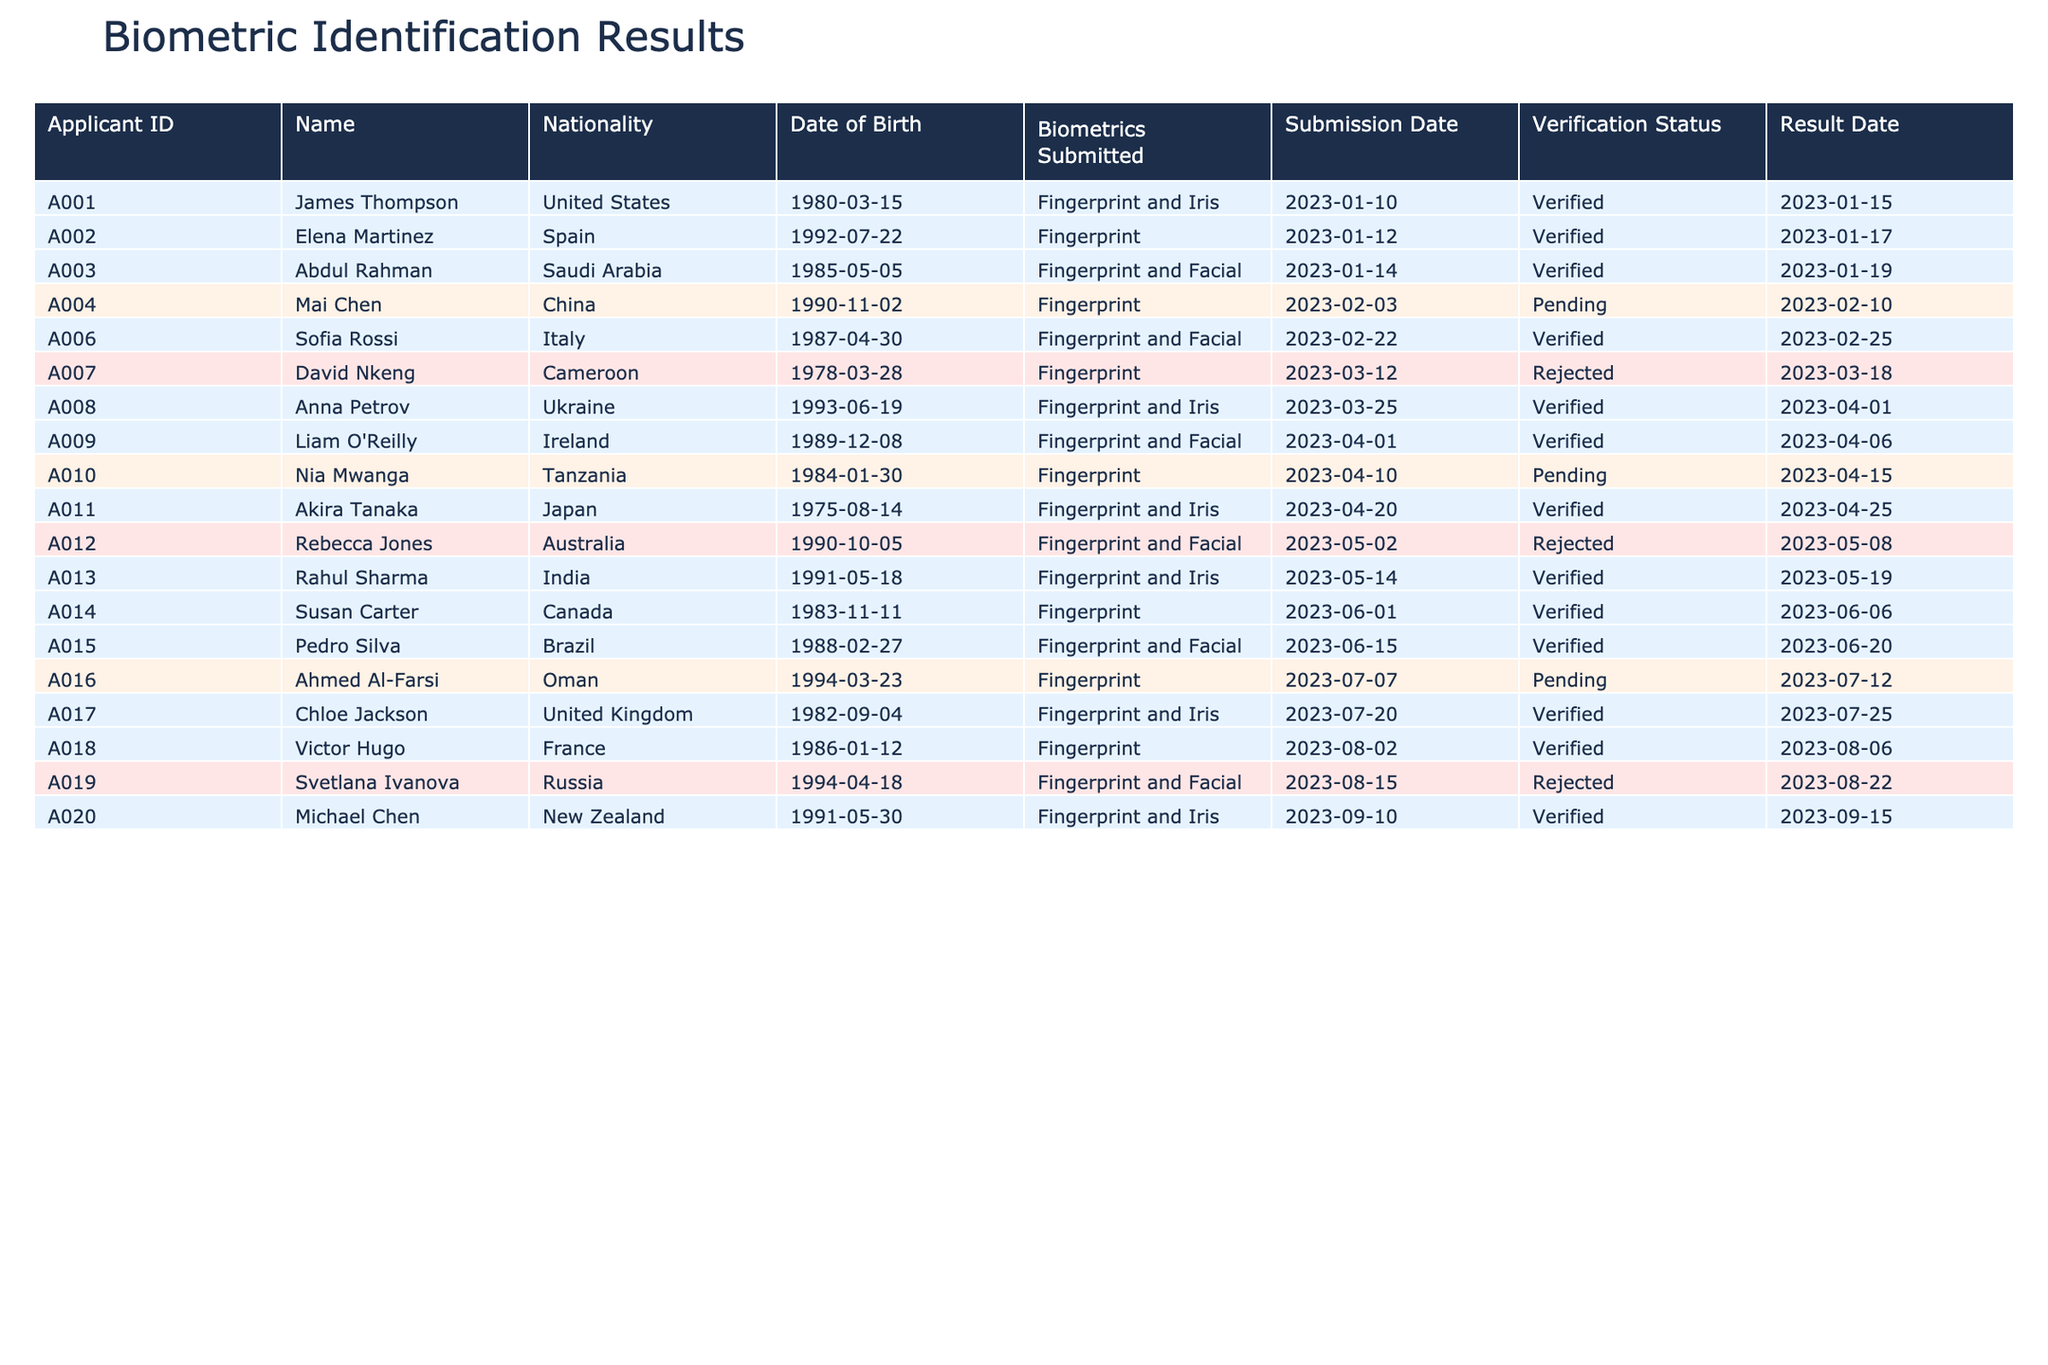What is the verification status of applicant A004, Mai Chen? The verification status for Mai Chen (A004) is listed under the column "Verification Status." Upon reviewing the table, it indicates "Pending."
Answer: Pending How many applicants have submitted biometrics through fingerprint only? To determine this, we look for rows where "Biometrics Submitted" equals "Fingerprint" and count the occurrences. By inspecting the table, there are 6 applicants matching this criterion: A002, A004, A007, A010, A014, and A018.
Answer: 6 Did any applicants from the United Kingdom receive a verified status? We check the verification status for the applicant from the United Kingdom. In the table, for Chloe Jackson (A017), the verification status is "Verified." This confirms that at least one applicant from the United Kingdom was verified.
Answer: Yes What is the average age of the applicants who were rejected based on their date of birth? To find the average age of rejected applicants, first, we identify those applicants from the table: A007 (David Nkeng), A012 (Rebecca Jones), and A019 (Svetlana Ivanova). Their birth years are 1978, 1990, and 1994, respectively. As of the current year 2023, the ages are 45, 33, and 29. The average age is calculated as follows: (45 + 33 + 29) / 3 = 35.67, rounded to 36.
Answer: 36 How many applicants from the Arab region (Saudi Arabia, Oman) submitted their biometrics? We need to check the nationalities of applicants from the Arab region. In the table, Abdul Rahman (A003) from Saudi Arabia and Ahmed Al-Farsi (A016) from Oman are accounted for, giving a total of 2 applicants from that region.
Answer: 2 